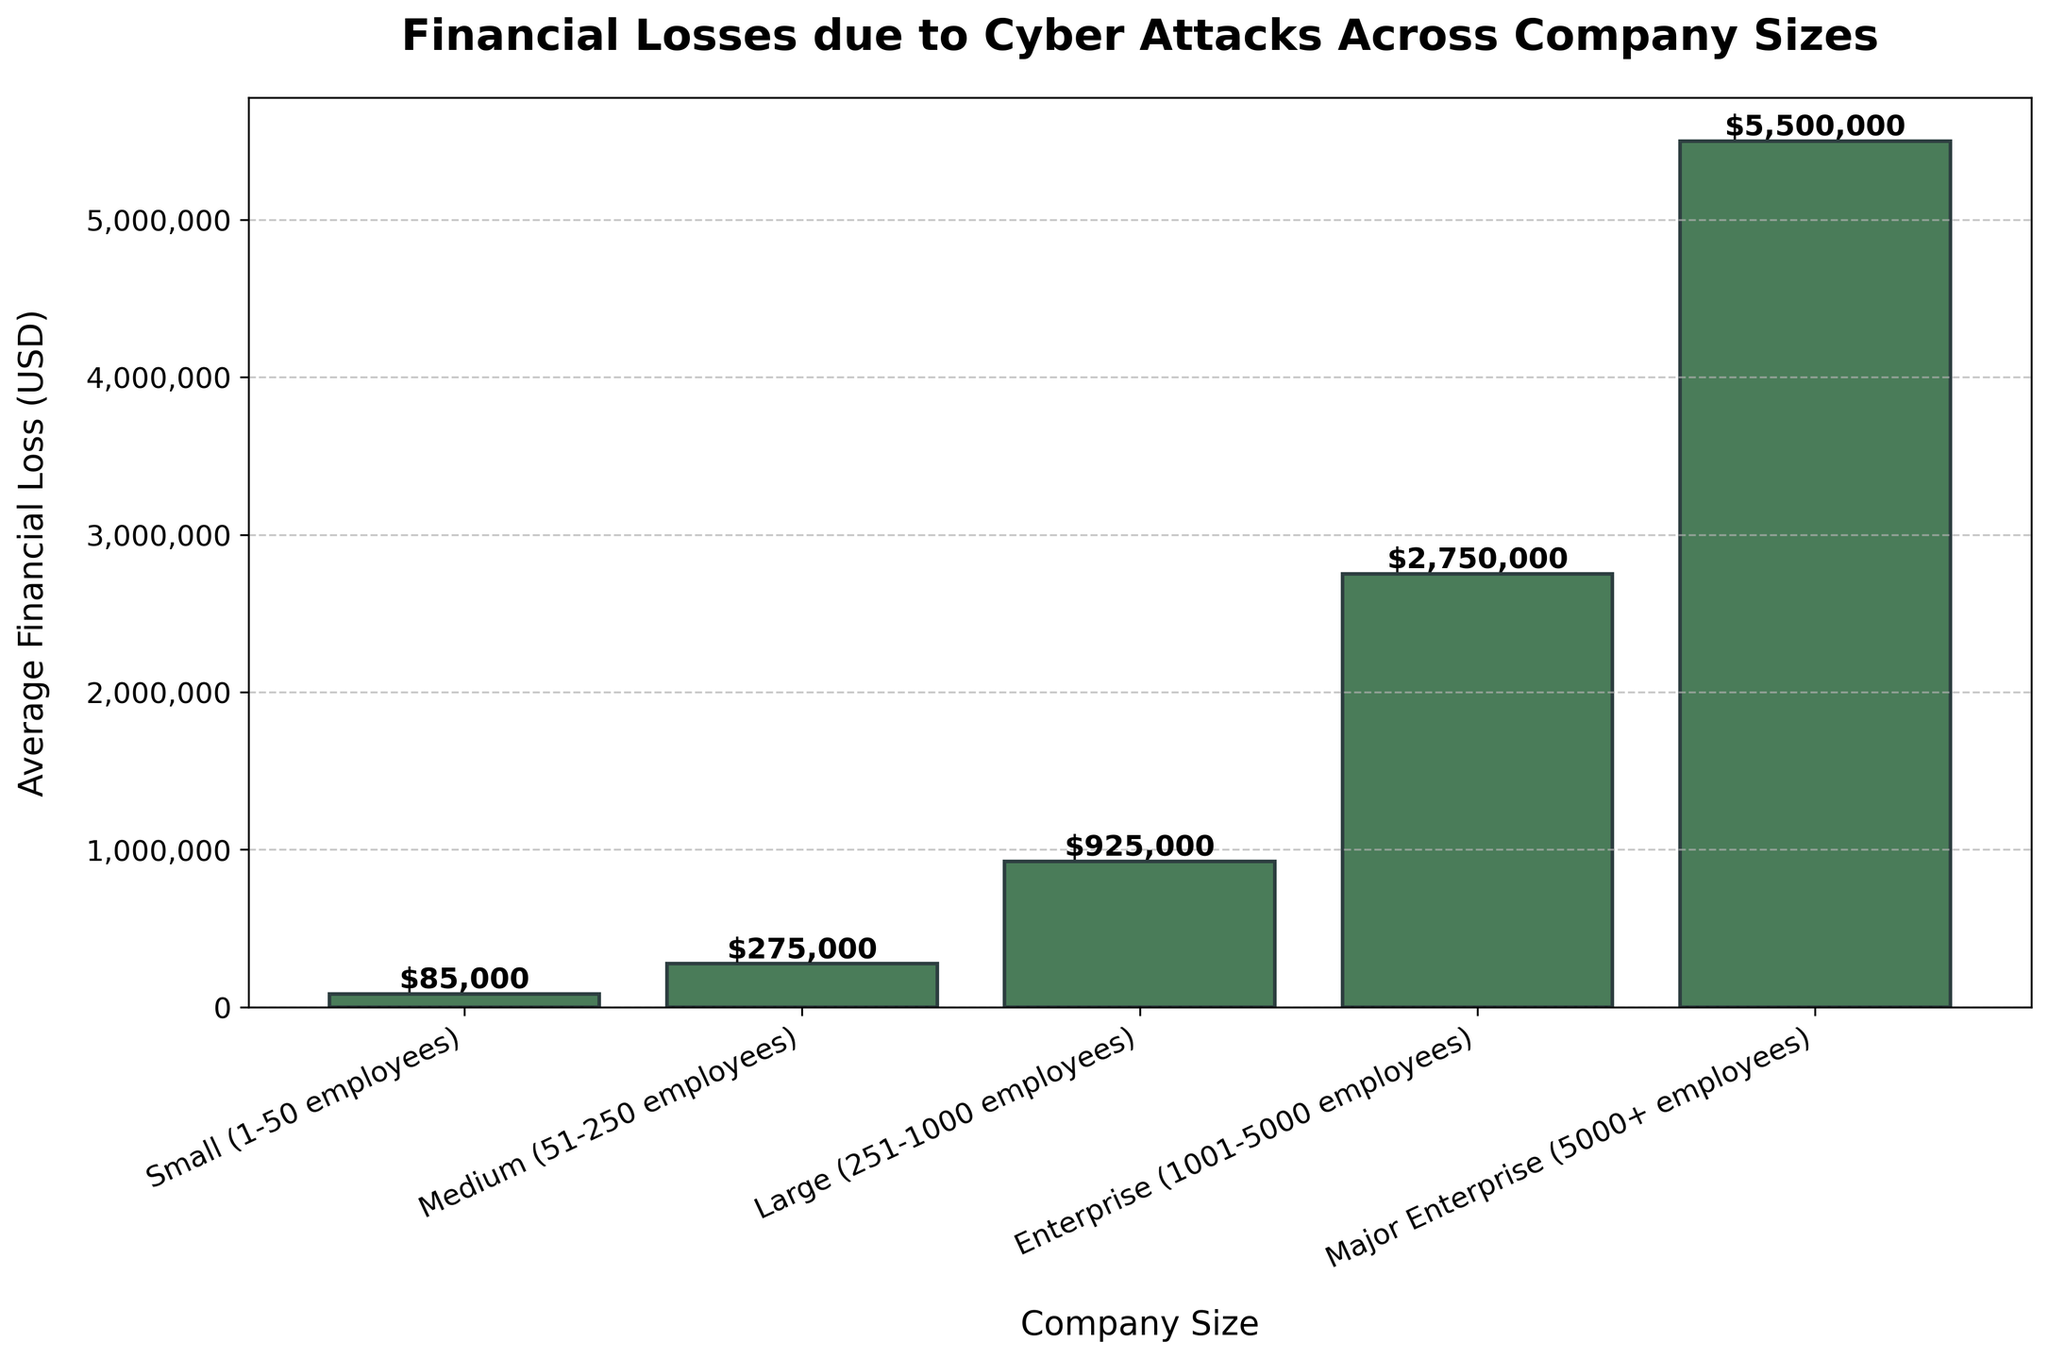What is the financial loss for a small company (1-50 employees) due to a cyber attack? The bar associated with "Small (1-50 employees)" is labeled with the dollar amount on top. It reads $85,000.
Answer: $85,000 Which company size experiences the highest financial loss due to cyber attacks? By comparing the height of all the bars, the bar for "Major Enterprise (5000+ employees)" is the tallest, indicating the highest loss.
Answer: Major Enterprise (5000+ employees) How much more does a major enterprise (5000+ employees) lose compared to an enterprise (1001-5000 employees) due to a cyber attack? The financial loss for a Major Enterprise is $5,500,000 and for an Enterprise it is $2,750,000. Subtract the Enterprise loss from the Major Enterprise loss: $5,500,000 - $2,750,000 = $2,750,000.
Answer: $2,750,000 What is the total financial loss combining small, medium, and large companies? Add the financial losses for Small ($85,000), Medium ($275,000), and Large ($925,000) companies: $85,000 + $275,000 + $925,000 = $1,285,000.
Answer: $1,285,000 Which company size has a financial loss that is closest to $1,000,000? By examining the bars, the financial loss for a Large company (251-1000 employees) is $925,000, which is closest to $1,000,000.
Answer: Large (251-1000 employees) How does the financial loss for medium-sized companies (51-250 employees) compare to small companies (1-50 employees)? The bar for Medium companies is higher than the bar for Small companies. The financial loss is $275,000 compared to $85,000.
Answer: Medium companies lose more What percentage of the financial loss of Major Enterprises (5000+ employees) is that of Large companies (251-1000 employees)? Divide the loss of Large companies ($925,000) by the loss of Major Enterprises ($5,500,000) and multiply by 100: ($925,000 / $5,500,000) * 100 ≈ 16.82%.
Answer: Approximately 16.82% Between which two company sizes is the financial loss difference equal to $650,000? The financial loss for Large (251-1000 employees) is $925,000 and for Medium (51-250 employees) is $275,000. The difference is $925,000 - $275,000 = $650,000.
Answer: Large (251-1000 employees) & Medium (51-250 employees) What is the average financial loss incurred by Enterprise (1001-5000 employees) and Major Enterprise (5000+ employees) due to cyber attacks? Add the financial losses for Enterprise ($2,750,000) and Major Enterprise ($5,500,000), then divide by 2: ($2,750,000 + $5,500,000) / 2 = $4,125,000.
Answer: $4,125,000 